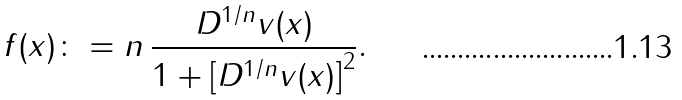Convert formula to latex. <formula><loc_0><loc_0><loc_500><loc_500>f ( x ) \colon = n \, \frac { D ^ { 1 / n } v ( x ) } { 1 + \left [ D ^ { 1 / n } v ( x ) \right ] ^ { 2 } } .</formula> 